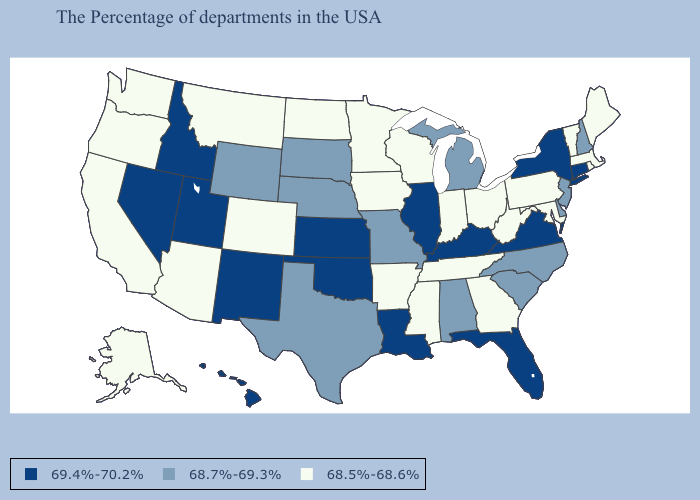What is the highest value in states that border Nevada?
Be succinct. 69.4%-70.2%. Does Wyoming have the same value as Indiana?
Write a very short answer. No. What is the value of Oklahoma?
Give a very brief answer. 69.4%-70.2%. Name the states that have a value in the range 69.4%-70.2%?
Answer briefly. Connecticut, New York, Virginia, Florida, Kentucky, Illinois, Louisiana, Kansas, Oklahoma, New Mexico, Utah, Idaho, Nevada, Hawaii. Name the states that have a value in the range 68.7%-69.3%?
Be succinct. New Hampshire, New Jersey, Delaware, North Carolina, South Carolina, Michigan, Alabama, Missouri, Nebraska, Texas, South Dakota, Wyoming. What is the highest value in states that border South Dakota?
Keep it brief. 68.7%-69.3%. What is the value of Connecticut?
Give a very brief answer. 69.4%-70.2%. Does California have the highest value in the West?
Answer briefly. No. What is the value of Virginia?
Answer briefly. 69.4%-70.2%. Does Indiana have the lowest value in the USA?
Short answer required. Yes. Name the states that have a value in the range 68.7%-69.3%?
Give a very brief answer. New Hampshire, New Jersey, Delaware, North Carolina, South Carolina, Michigan, Alabama, Missouri, Nebraska, Texas, South Dakota, Wyoming. Does North Carolina have a lower value than Tennessee?
Keep it brief. No. What is the value of Minnesota?
Concise answer only. 68.5%-68.6%. What is the value of North Carolina?
Be succinct. 68.7%-69.3%. Does the map have missing data?
Give a very brief answer. No. 